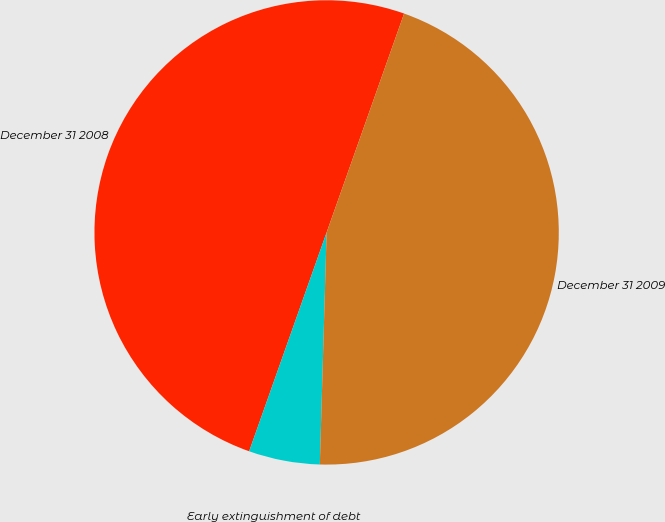Convert chart. <chart><loc_0><loc_0><loc_500><loc_500><pie_chart><fcel>December 31 2008<fcel>Early extinguishment of debt<fcel>December 31 2009<nl><fcel>50.0%<fcel>4.95%<fcel>45.05%<nl></chart> 